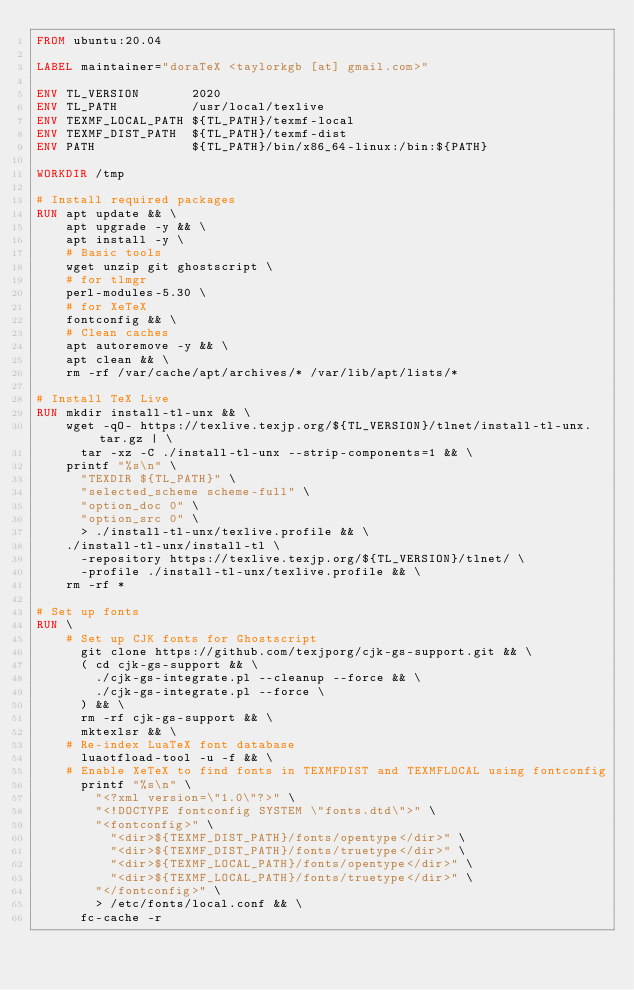<code> <loc_0><loc_0><loc_500><loc_500><_Dockerfile_>FROM ubuntu:20.04

LABEL maintainer="doraTeX <taylorkgb [at] gmail.com>"

ENV TL_VERSION       2020
ENV TL_PATH          /usr/local/texlive
ENV TEXMF_LOCAL_PATH ${TL_PATH}/texmf-local
ENV TEXMF_DIST_PATH  ${TL_PATH}/texmf-dist
ENV PATH             ${TL_PATH}/bin/x86_64-linux:/bin:${PATH}

WORKDIR /tmp

# Install required packages
RUN apt update && \
    apt upgrade -y && \
    apt install -y \
    # Basic tools
    wget unzip git ghostscript \
    # for tlmgr
    perl-modules-5.30 \
    # for XeTeX
    fontconfig && \
    # Clean caches
    apt autoremove -y && \
    apt clean && \
    rm -rf /var/cache/apt/archives/* /var/lib/apt/lists/*

# Install TeX Live
RUN mkdir install-tl-unx && \
    wget -qO- https://texlive.texjp.org/${TL_VERSION}/tlnet/install-tl-unx.tar.gz | \
      tar -xz -C ./install-tl-unx --strip-components=1 && \
    printf "%s\n" \
      "TEXDIR ${TL_PATH}" \
      "selected_scheme scheme-full" \
      "option_doc 0" \
      "option_src 0" \
      > ./install-tl-unx/texlive.profile && \
    ./install-tl-unx/install-tl \
      -repository https://texlive.texjp.org/${TL_VERSION}/tlnet/ \
      -profile ./install-tl-unx/texlive.profile && \
    rm -rf *

# Set up fonts
RUN \
    # Set up CJK fonts for Ghostscript
      git clone https://github.com/texjporg/cjk-gs-support.git && \
      ( cd cjk-gs-support && \
        ./cjk-gs-integrate.pl --cleanup --force && \
        ./cjk-gs-integrate.pl --force \
      ) && \
      rm -rf cjk-gs-support && \
      mktexlsr && \
    # Re-index LuaTeX font database
      luaotfload-tool -u -f && \
    # Enable XeTeX to find fonts in TEXMFDIST and TEXMFLOCAL using fontconfig
      printf "%s\n" \
        "<?xml version=\"1.0\"?>" \
        "<!DOCTYPE fontconfig SYSTEM \"fonts.dtd\">" \
        "<fontconfig>" \
          "<dir>${TEXMF_DIST_PATH}/fonts/opentype</dir>" \
          "<dir>${TEXMF_DIST_PATH}/fonts/truetype</dir>" \
          "<dir>${TEXMF_LOCAL_PATH}/fonts/opentype</dir>" \
          "<dir>${TEXMF_LOCAL_PATH}/fonts/truetype</dir>" \
        "</fontconfig>" \
        > /etc/fonts/local.conf && \
      fc-cache -r
</code> 